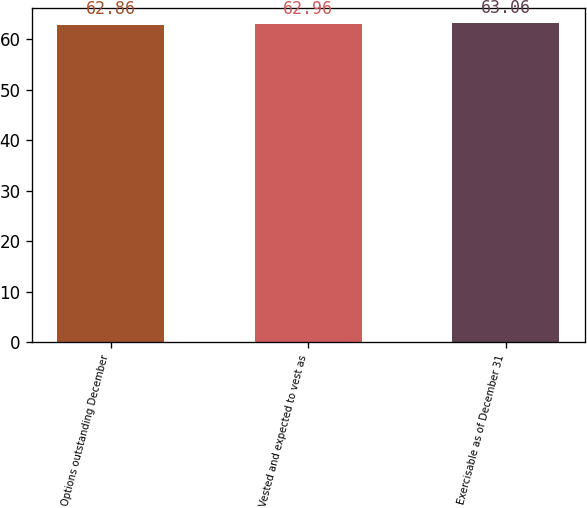Convert chart to OTSL. <chart><loc_0><loc_0><loc_500><loc_500><bar_chart><fcel>Options outstanding December<fcel>Vested and expected to vest as<fcel>Exercisable as of December 31<nl><fcel>62.86<fcel>62.96<fcel>63.06<nl></chart> 